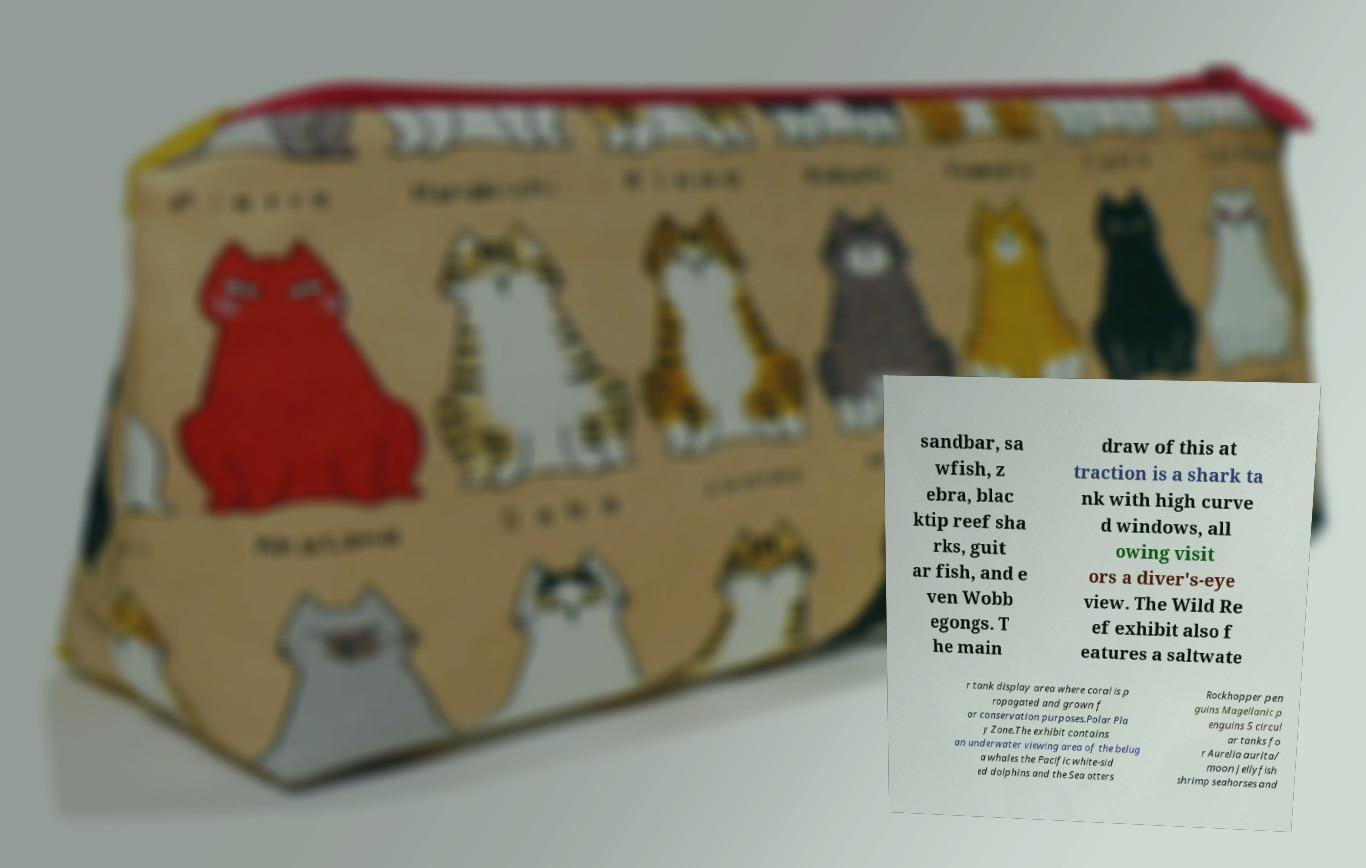Could you assist in decoding the text presented in this image and type it out clearly? sandbar, sa wfish, z ebra, blac ktip reef sha rks, guit ar fish, and e ven Wobb egongs. T he main draw of this at traction is a shark ta nk with high curve d windows, all owing visit ors a diver's-eye view. The Wild Re ef exhibit also f eatures a saltwate r tank display area where coral is p ropagated and grown f or conservation purposes.Polar Pla y Zone.The exhibit contains an underwater viewing area of the belug a whales the Pacific white-sid ed dolphins and the Sea otters Rockhopper pen guins Magellanic p enguins 5 circul ar tanks fo r Aurelia aurita/ moon jellyfish shrimp seahorses and 